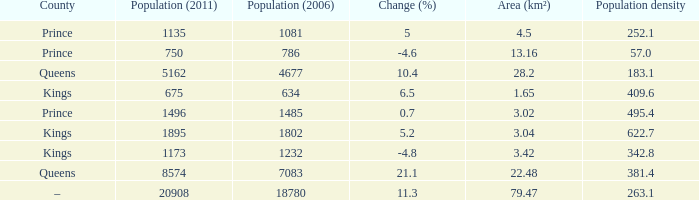What was the spatial coverage (km²) when the population (2011) was 8574, and the population density surpassed 38 None. 